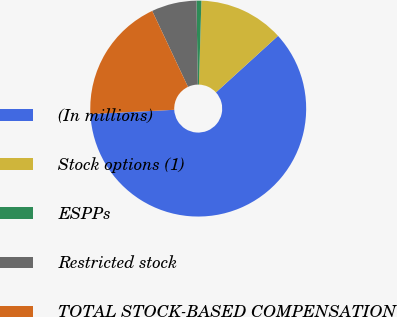<chart> <loc_0><loc_0><loc_500><loc_500><pie_chart><fcel>(In millions)<fcel>Stock options (1)<fcel>ESPPs<fcel>Restricted stock<fcel>TOTAL STOCK-BASED COMPENSATION<nl><fcel>60.96%<fcel>12.77%<fcel>0.73%<fcel>6.75%<fcel>18.8%<nl></chart> 